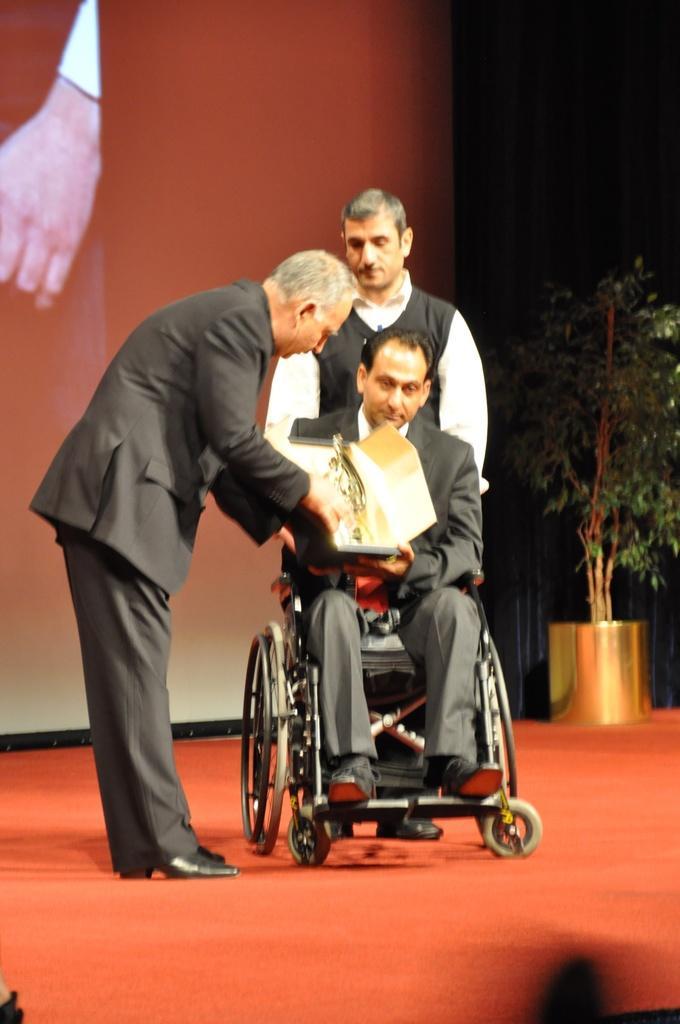Describe this image in one or two sentences. In this image, there is a carpet on the floor, at the middle there is a man sitting on the wheel chair, at the left side there is a man standing and he is wearing a black color coat, he is holding some object. 